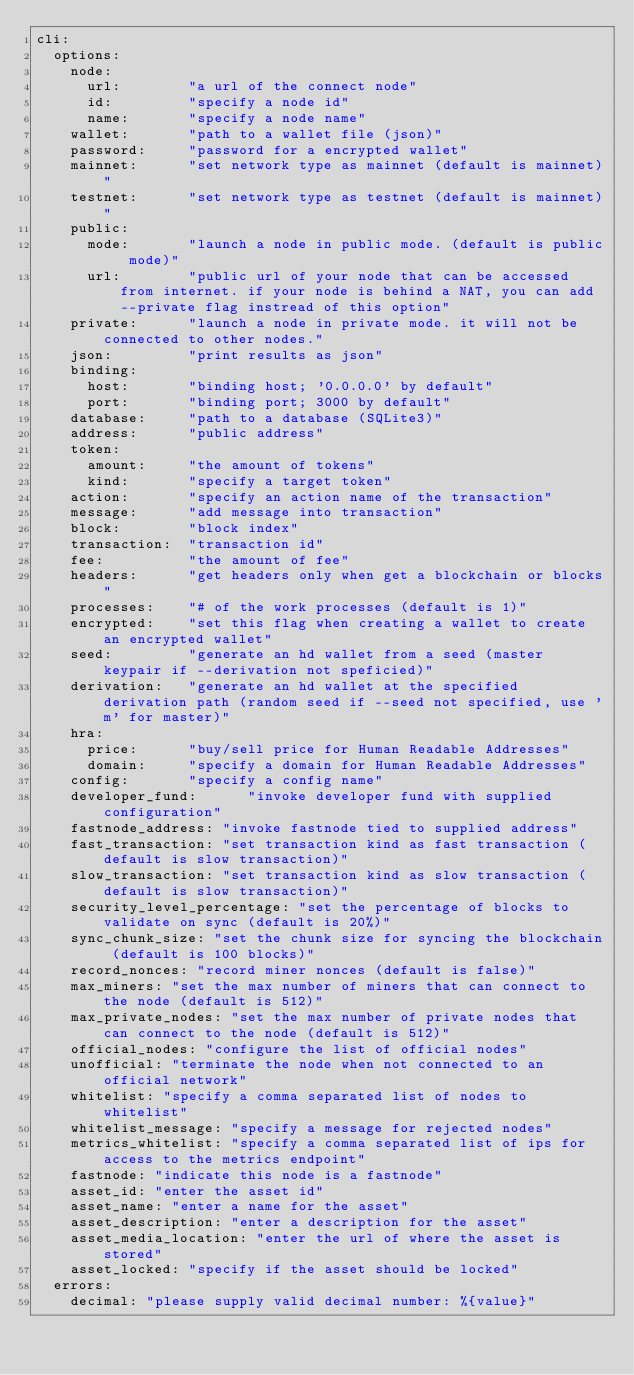<code> <loc_0><loc_0><loc_500><loc_500><_YAML_>cli:
  options:
    node:
      url:        "a url of the connect node"
      id:         "specify a node id"
      name:       "specify a node name"
    wallet:       "path to a wallet file (json)"
    password:     "password for a encrypted wallet"
    mainnet:      "set network type as mainnet (default is mainnet)"
    testnet:      "set network type as testnet (default is mainnet)"
    public:
      mode:       "launch a node in public mode. (default is public mode)"
      url:        "public url of your node that can be accessed from internet. if your node is behind a NAT, you can add --private flag instread of this option"
    private:      "launch a node in private mode. it will not be connected to other nodes."
    json:         "print results as json"
    binding:
      host:       "binding host; '0.0.0.0' by default"
      port:       "binding port; 3000 by default"
    database:     "path to a database (SQLite3)"
    address:      "public address"
    token:
      amount:     "the amount of tokens"
      kind:       "specify a target token"
    action:       "specify an action name of the transaction"
    message:      "add message into transaction"
    block:        "block index"
    transaction:  "transaction id"
    fee:          "the amount of fee"
    headers:      "get headers only when get a blockchain or blocks"
    processes:    "# of the work processes (default is 1)"
    encrypted:    "set this flag when creating a wallet to create an encrypted wallet"
    seed:         "generate an hd wallet from a seed (master keypair if --derivation not speficied)"
    derivation:   "generate an hd wallet at the specified derivation path (random seed if --seed not specified, use 'm' for master)"
    hra:
      price:      "buy/sell price for Human Readable Addresses"
      domain:     "specify a domain for Human Readable Addresses"
    config:       "specify a config name"
    developer_fund:      "invoke developer fund with supplied configuration"
    fastnode_address: "invoke fastnode tied to supplied address"
    fast_transaction: "set transaction kind as fast transaction (default is slow transaction)"
    slow_transaction: "set transaction kind as slow transaction (default is slow transaction)"
    security_level_percentage: "set the percentage of blocks to validate on sync (default is 20%)"
    sync_chunk_size: "set the chunk size for syncing the blockchain (default is 100 blocks)"
    record_nonces: "record miner nonces (default is false)"
    max_miners: "set the max number of miners that can connect to the node (default is 512)"
    max_private_nodes: "set the max number of private nodes that can connect to the node (default is 512)"
    official_nodes: "configure the list of official nodes"
    unofficial: "terminate the node when not connected to an official network"
    whitelist: "specify a comma separated list of nodes to whitelist"
    whitelist_message: "specify a message for rejected nodes"
    metrics_whitelist: "specify a comma separated list of ips for access to the metrics endpoint"
    fastnode: "indicate this node is a fastnode"
    asset_id: "enter the asset id"
    asset_name: "enter a name for the asset"
    asset_description: "enter a description for the asset"
    asset_media_location: "enter the url of where the asset is stored"
    asset_locked: "specify if the asset should be locked"
  errors:
    decimal: "please supply valid decimal number: %{value}" 
</code> 